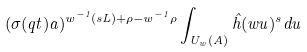Convert formula to latex. <formula><loc_0><loc_0><loc_500><loc_500>( \sigma ( q t ) a ) ^ { w ^ { - 1 } ( s L ) + \rho - w ^ { - 1 } \rho } \int _ { { U _ { w } } ( { A } ) } \hat { h } ( w u ) ^ { s } d u</formula> 